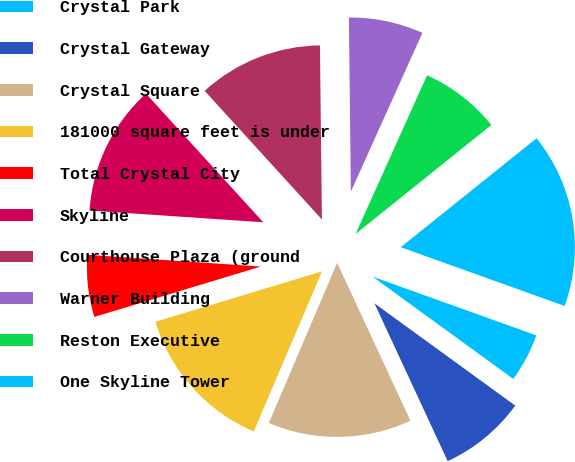Convert chart to OTSL. <chart><loc_0><loc_0><loc_500><loc_500><pie_chart><fcel>Crystal Park<fcel>Crystal Gateway<fcel>Crystal Square<fcel>181000 square feet is under<fcel>Total Crystal City<fcel>Skyline<fcel>Courthouse Plaza (ground<fcel>Warner Building<fcel>Reston Executive<fcel>One Skyline Tower<nl><fcel>4.52%<fcel>8.08%<fcel>13.33%<fcel>13.91%<fcel>5.75%<fcel>12.16%<fcel>11.58%<fcel>6.92%<fcel>7.5%<fcel>16.24%<nl></chart> 